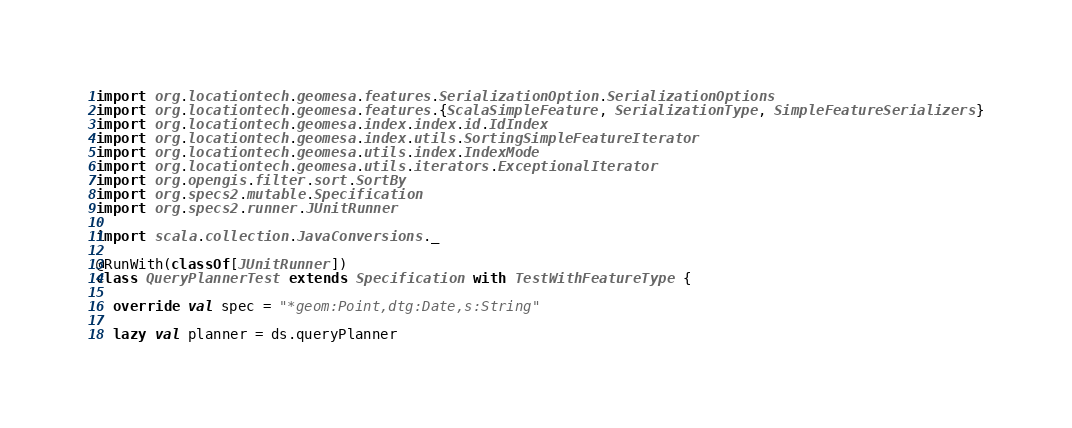<code> <loc_0><loc_0><loc_500><loc_500><_Scala_>import org.locationtech.geomesa.features.SerializationOption.SerializationOptions
import org.locationtech.geomesa.features.{ScalaSimpleFeature, SerializationType, SimpleFeatureSerializers}
import org.locationtech.geomesa.index.index.id.IdIndex
import org.locationtech.geomesa.index.utils.SortingSimpleFeatureIterator
import org.locationtech.geomesa.utils.index.IndexMode
import org.locationtech.geomesa.utils.iterators.ExceptionalIterator
import org.opengis.filter.sort.SortBy
import org.specs2.mutable.Specification
import org.specs2.runner.JUnitRunner

import scala.collection.JavaConversions._

@RunWith(classOf[JUnitRunner])
class QueryPlannerTest extends Specification with TestWithFeatureType {

  override val spec = "*geom:Point,dtg:Date,s:String"

  lazy val planner = ds.queryPlanner
</code> 